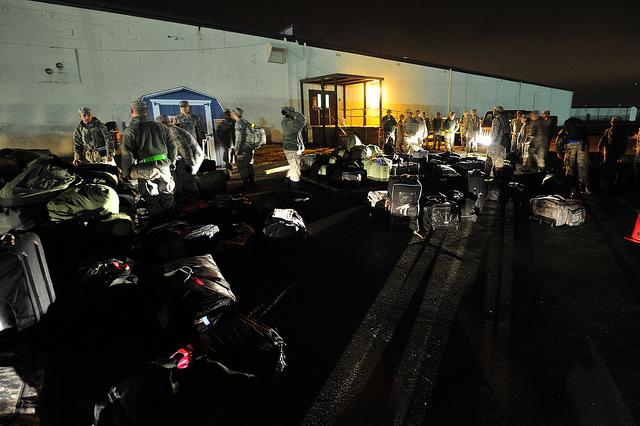<image>Why are there so many bags? It is unknown why there are so many bags. It could be due to customs, people traveling, or a meeting. Why are there so many bags? I don't know why there are so many bags. It could be because of customs, people at a shelter, people traveling, or any other reason. 